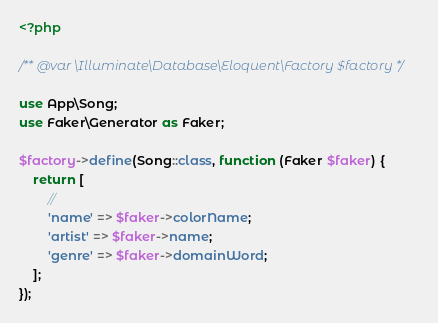Convert code to text. <code><loc_0><loc_0><loc_500><loc_500><_PHP_><?php

/** @var \Illuminate\Database\Eloquent\Factory $factory */

use App\Song;
use Faker\Generator as Faker;

$factory->define(Song::class, function (Faker $faker) {
    return [
        //
        'name' => $faker->colorName;
        'artist' => $faker->name;
        'genre' => $faker->domainWord;
    ];
});
</code> 